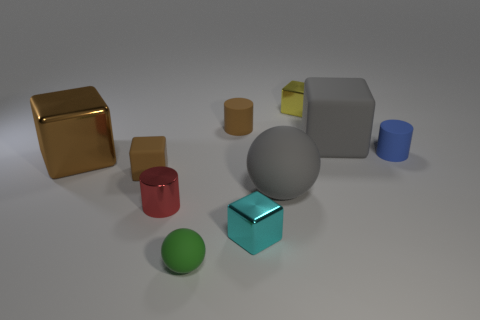Is the big shiny object the same shape as the yellow object?
Your response must be concise. Yes. Is there any other thing that has the same color as the small matte ball?
Your answer should be very brief. No. What color is the other small rubber thing that is the same shape as the small yellow thing?
Your answer should be compact. Brown. Is the number of tiny brown matte things that are behind the brown metal thing greater than the number of brown cubes?
Offer a terse response. No. The tiny rubber cylinder that is to the left of the yellow block is what color?
Your response must be concise. Brown. Is the size of the gray sphere the same as the cyan cube?
Keep it short and to the point. No. The yellow thing has what size?
Offer a very short reply. Small. The large thing that is the same color as the large rubber cube is what shape?
Keep it short and to the point. Sphere. Are there more small green matte balls than big cyan shiny cylinders?
Provide a short and direct response. Yes. What is the color of the cube that is on the right side of the small yellow object to the left of the tiny rubber thing that is on the right side of the cyan shiny thing?
Offer a terse response. Gray. 